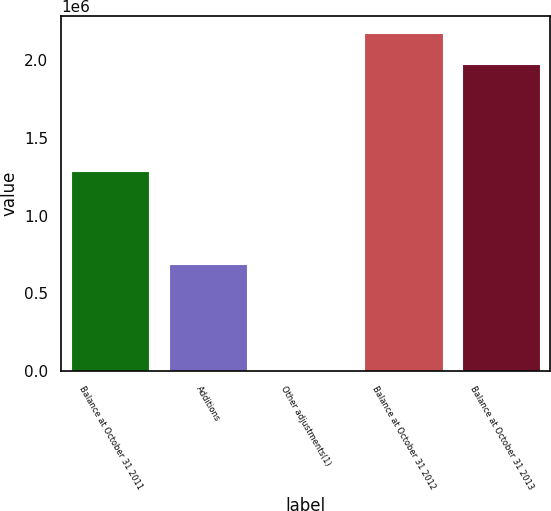Convert chart. <chart><loc_0><loc_0><loc_500><loc_500><bar_chart><fcel>Balance at October 31 2011<fcel>Additions<fcel>Other adjustments(1)<fcel>Balance at October 31 2012<fcel>Balance at October 31 2013<nl><fcel>1.28929e+06<fcel>687195<fcel>506<fcel>2.17362e+06<fcel>1.97597e+06<nl></chart> 